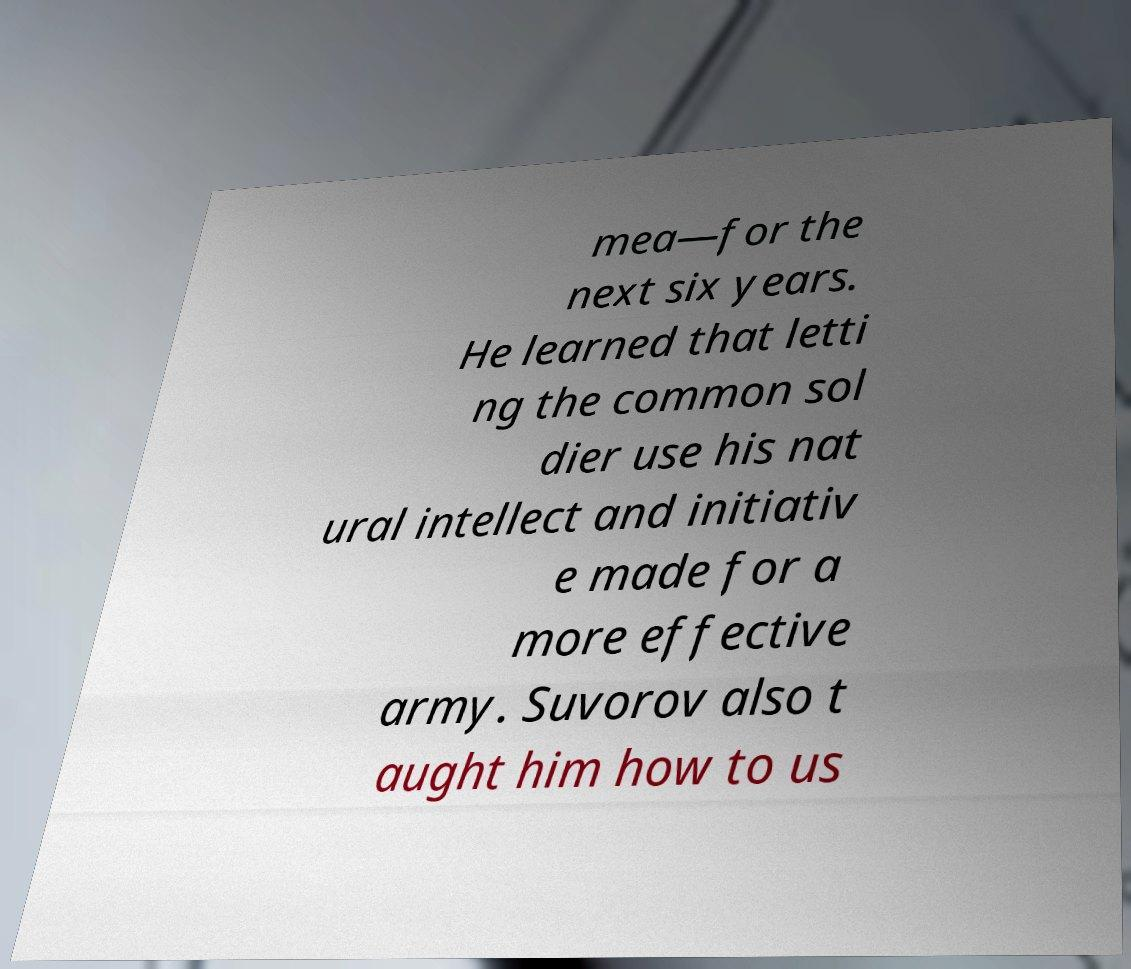For documentation purposes, I need the text within this image transcribed. Could you provide that? mea—for the next six years. He learned that letti ng the common sol dier use his nat ural intellect and initiativ e made for a more effective army. Suvorov also t aught him how to us 